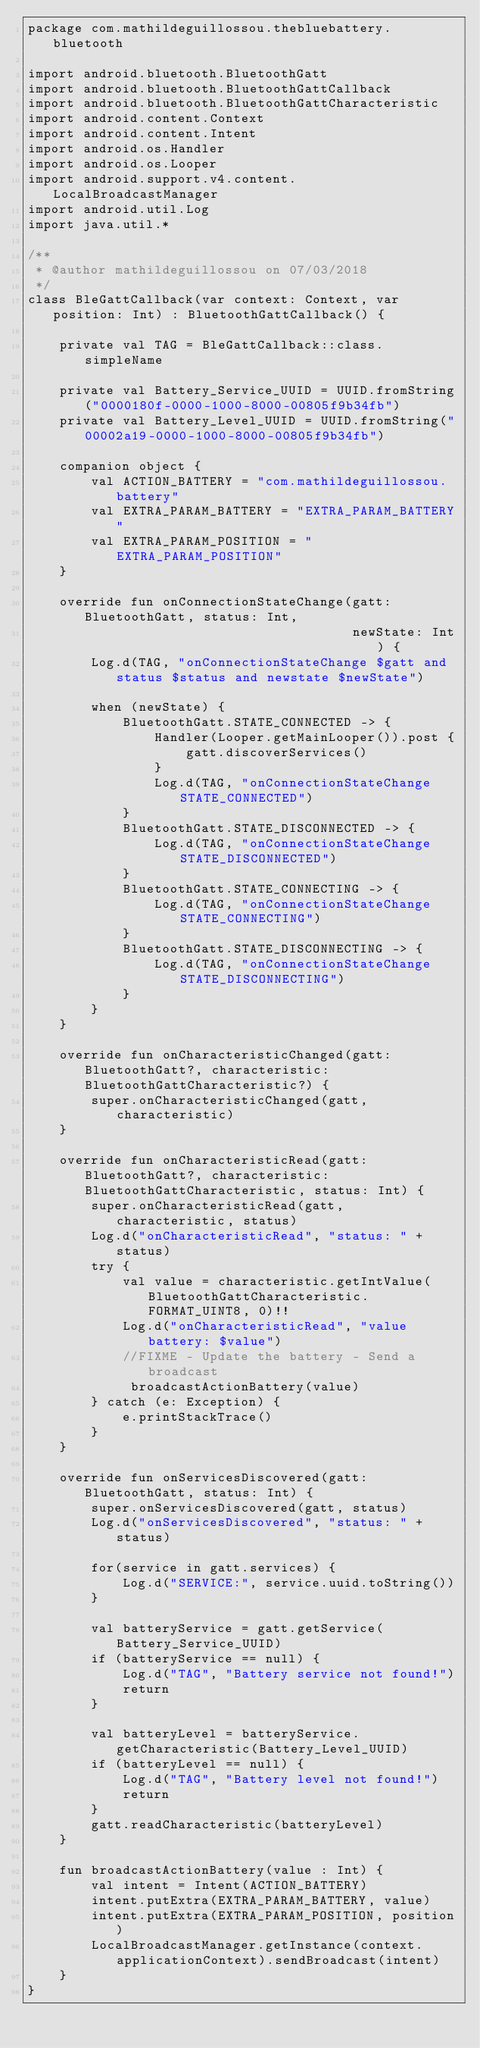<code> <loc_0><loc_0><loc_500><loc_500><_Kotlin_>package com.mathildeguillossou.thebluebattery.bluetooth

import android.bluetooth.BluetoothGatt
import android.bluetooth.BluetoothGattCallback
import android.bluetooth.BluetoothGattCharacteristic
import android.content.Context
import android.content.Intent
import android.os.Handler
import android.os.Looper
import android.support.v4.content.LocalBroadcastManager
import android.util.Log
import java.util.*

/**
 * @author mathildeguillossou on 07/03/2018
 */
class BleGattCallback(var context: Context, var position: Int) : BluetoothGattCallback() {

    private val TAG = BleGattCallback::class.simpleName

    private val Battery_Service_UUID = UUID.fromString("0000180f-0000-1000-8000-00805f9b34fb")
    private val Battery_Level_UUID = UUID.fromString("00002a19-0000-1000-8000-00805f9b34fb")

    companion object {
        val ACTION_BATTERY = "com.mathildeguillossou.battery"
        val EXTRA_PARAM_BATTERY = "EXTRA_PARAM_BATTERY"
        val EXTRA_PARAM_POSITION = "EXTRA_PARAM_POSITION"
    }

    override fun onConnectionStateChange(gatt: BluetoothGatt, status: Int,
                                         newState: Int) {
        Log.d(TAG, "onConnectionStateChange $gatt and status $status and newstate $newState")

        when (newState) {
            BluetoothGatt.STATE_CONNECTED -> {
                Handler(Looper.getMainLooper()).post {
                    gatt.discoverServices()
                }
                Log.d(TAG, "onConnectionStateChange STATE_CONNECTED")
            }
            BluetoothGatt.STATE_DISCONNECTED -> {
                Log.d(TAG, "onConnectionStateChange STATE_DISCONNECTED")
            }
            BluetoothGatt.STATE_CONNECTING -> {
                Log.d(TAG, "onConnectionStateChange STATE_CONNECTING")
            }
            BluetoothGatt.STATE_DISCONNECTING -> {
                Log.d(TAG, "onConnectionStateChange STATE_DISCONNECTING")
            }
        }
    }

    override fun onCharacteristicChanged(gatt: BluetoothGatt?, characteristic: BluetoothGattCharacteristic?) {
        super.onCharacteristicChanged(gatt, characteristic)
    }

    override fun onCharacteristicRead(gatt: BluetoothGatt?, characteristic: BluetoothGattCharacteristic, status: Int) {
        super.onCharacteristicRead(gatt, characteristic, status)
        Log.d("onCharacteristicRead", "status: " + status)
        try {
            val value = characteristic.getIntValue(BluetoothGattCharacteristic.FORMAT_UINT8, 0)!!
            Log.d("onCharacteristicRead", "value battery: $value")
            //FIXME - Update the battery - Send a broadcast
             broadcastActionBattery(value)
        } catch (e: Exception) {
            e.printStackTrace()
        }
    }

    override fun onServicesDiscovered(gatt: BluetoothGatt, status: Int) {
        super.onServicesDiscovered(gatt, status)
        Log.d("onServicesDiscovered", "status: " + status)

        for(service in gatt.services) {
            Log.d("SERVICE:", service.uuid.toString())
        }

        val batteryService = gatt.getService(Battery_Service_UUID)
        if (batteryService == null) {
            Log.d("TAG", "Battery service not found!")
            return
        }

        val batteryLevel = batteryService.getCharacteristic(Battery_Level_UUID)
        if (batteryLevel == null) {
            Log.d("TAG", "Battery level not found!")
            return
        }
        gatt.readCharacteristic(batteryLevel)
    }

    fun broadcastActionBattery(value : Int) {
        val intent = Intent(ACTION_BATTERY)
        intent.putExtra(EXTRA_PARAM_BATTERY, value)
        intent.putExtra(EXTRA_PARAM_POSITION, position)
        LocalBroadcastManager.getInstance(context.applicationContext).sendBroadcast(intent)
    }
}</code> 